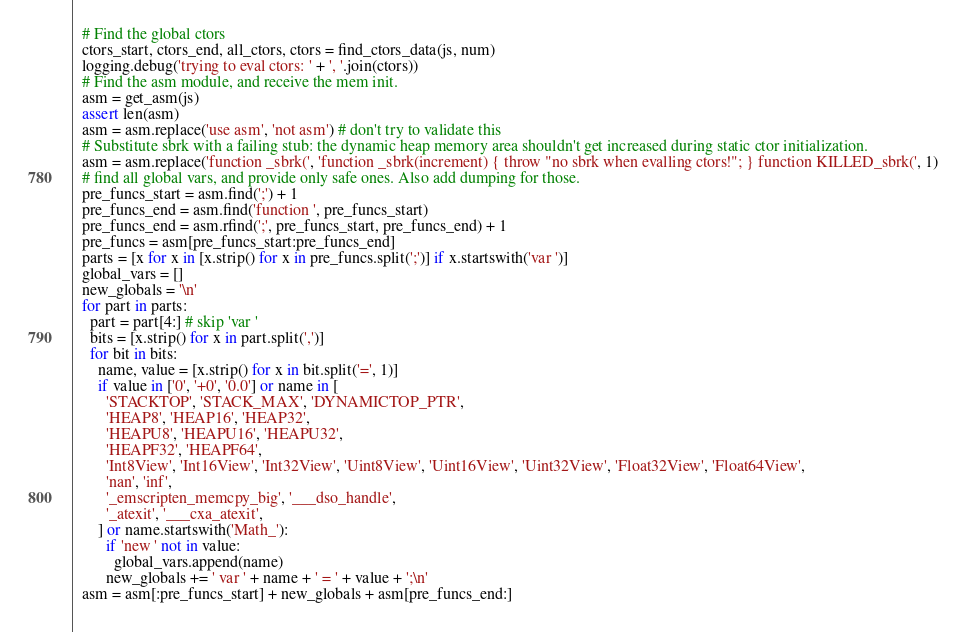<code> <loc_0><loc_0><loc_500><loc_500><_Python_>  # Find the global ctors
  ctors_start, ctors_end, all_ctors, ctors = find_ctors_data(js, num)
  logging.debug('trying to eval ctors: ' + ', '.join(ctors))
  # Find the asm module, and receive the mem init.
  asm = get_asm(js)
  assert len(asm)
  asm = asm.replace('use asm', 'not asm') # don't try to validate this
  # Substitute sbrk with a failing stub: the dynamic heap memory area shouldn't get increased during static ctor initialization.
  asm = asm.replace('function _sbrk(', 'function _sbrk(increment) { throw "no sbrk when evalling ctors!"; } function KILLED_sbrk(', 1)
  # find all global vars, and provide only safe ones. Also add dumping for those.
  pre_funcs_start = asm.find(';') + 1
  pre_funcs_end = asm.find('function ', pre_funcs_start)
  pre_funcs_end = asm.rfind(';', pre_funcs_start, pre_funcs_end) + 1
  pre_funcs = asm[pre_funcs_start:pre_funcs_end]
  parts = [x for x in [x.strip() for x in pre_funcs.split(';')] if x.startswith('var ')]
  global_vars = []
  new_globals = '\n'
  for part in parts:
    part = part[4:] # skip 'var '
    bits = [x.strip() for x in part.split(',')]
    for bit in bits:
      name, value = [x.strip() for x in bit.split('=', 1)]
      if value in ['0', '+0', '0.0'] or name in [
        'STACKTOP', 'STACK_MAX', 'DYNAMICTOP_PTR',
        'HEAP8', 'HEAP16', 'HEAP32',
        'HEAPU8', 'HEAPU16', 'HEAPU32',
        'HEAPF32', 'HEAPF64',
        'Int8View', 'Int16View', 'Int32View', 'Uint8View', 'Uint16View', 'Uint32View', 'Float32View', 'Float64View',
        'nan', 'inf',
        '_emscripten_memcpy_big', '___dso_handle',
        '_atexit', '___cxa_atexit',
      ] or name.startswith('Math_'):
        if 'new ' not in value:
          global_vars.append(name)
        new_globals += ' var ' + name + ' = ' + value + ';\n'
  asm = asm[:pre_funcs_start] + new_globals + asm[pre_funcs_end:]</code> 